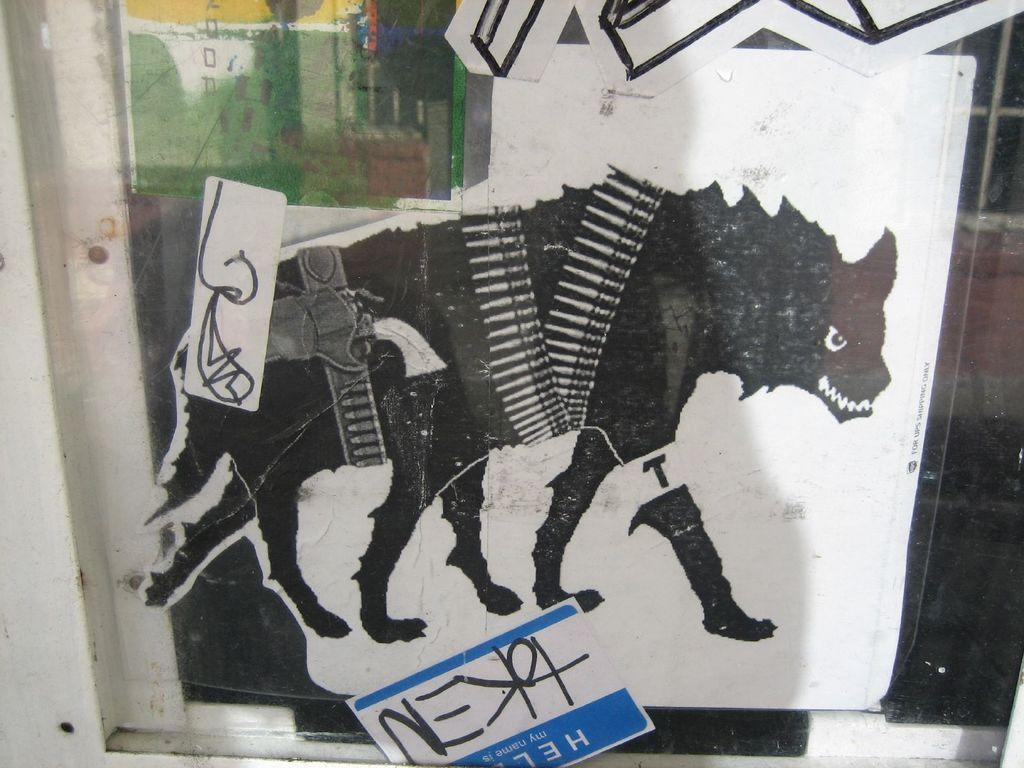What is depicted in the painting in the image? There is a painting of an animal in the image. What else can be seen in the image besides the painting? There is a board with text and a reflection of a building on the glass in the image. Can you see any veins in the animal depicted in the painting? There is no indication of veins in the animal depicted in the painting, as it is a two-dimensional representation. 